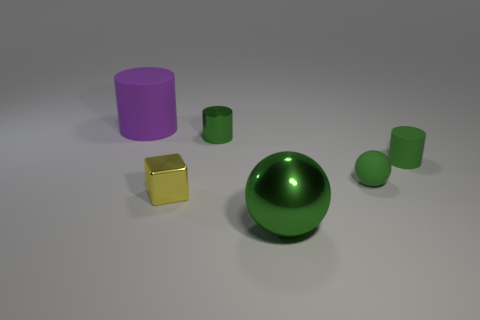There is a matte thing that is behind the green cylinder that is left of the matte cylinder to the right of the big matte cylinder; what size is it?
Keep it short and to the point. Large. What is the material of the small yellow object?
Provide a succinct answer. Metal. Are the large purple cylinder and the green object right of the tiny green ball made of the same material?
Your answer should be very brief. Yes. Are there any other things of the same color as the metal ball?
Provide a short and direct response. Yes. There is a small rubber thing left of the matte cylinder right of the large cylinder; is there a tiny green rubber thing behind it?
Your response must be concise. Yes. The shiny ball has what color?
Your answer should be compact. Green. Are there any tiny yellow blocks right of the purple matte cylinder?
Your answer should be very brief. Yes. There is a large rubber thing; is its shape the same as the big object that is in front of the large matte thing?
Make the answer very short. No. How many other things are the same material as the small sphere?
Offer a terse response. 2. What is the color of the big thing that is right of the rubber cylinder left of the small green thing that is left of the shiny sphere?
Provide a succinct answer. Green. 